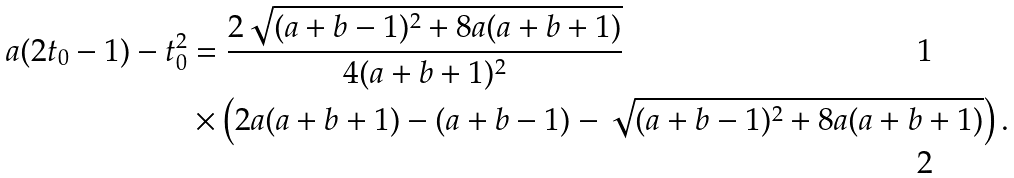Convert formula to latex. <formula><loc_0><loc_0><loc_500><loc_500>a ( 2 t _ { 0 } - 1 ) - t _ { 0 } ^ { 2 } & = \frac { 2 \sqrt { ( a + b - 1 ) ^ { 2 } + 8 a ( a + b + 1 ) } } { 4 ( a + b + 1 ) ^ { 2 } } \\ & \times \left ( 2 a ( a + b + 1 ) - ( a + b - 1 ) - \sqrt { ( a + b - 1 ) ^ { 2 } + 8 a ( a + b + 1 ) } \right ) .</formula> 